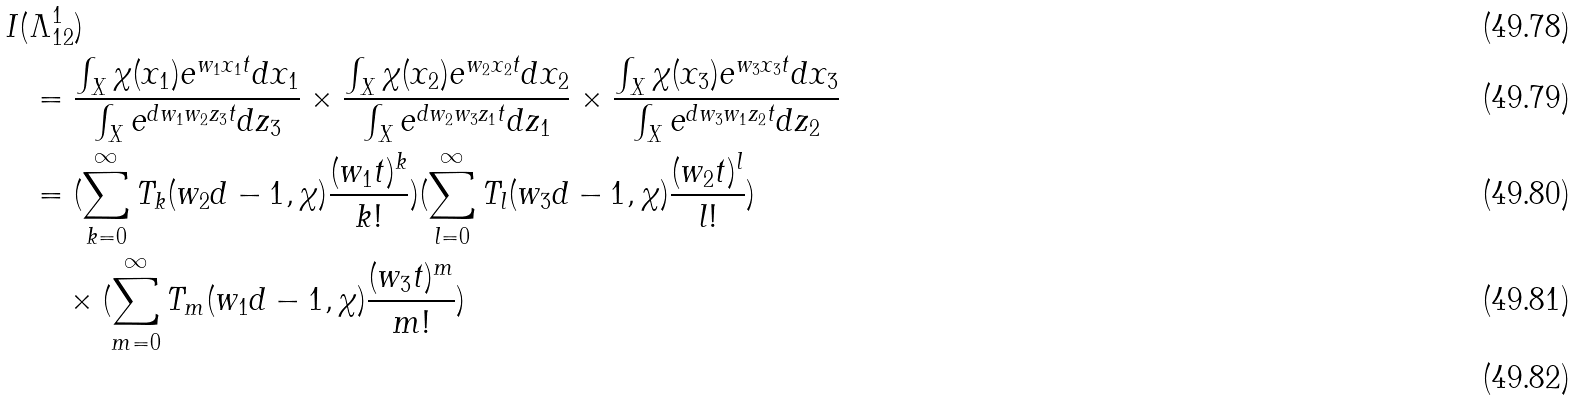Convert formula to latex. <formula><loc_0><loc_0><loc_500><loc_500>I ( & \Lambda _ { 1 2 } ^ { 1 } ) \\ & = \frac { \int _ { X } \chi ( x _ { 1 } ) e ^ { w _ { 1 } x _ { 1 } t } d x _ { 1 } } { \int _ { X } e ^ { d w _ { 1 } w _ { 2 } z _ { 3 } t } d z _ { 3 } } \times \frac { \int _ { X } \chi ( x _ { 2 } ) e ^ { w _ { 2 } x _ { 2 } t } d x _ { 2 } } { \int _ { X } e ^ { d w _ { 2 } w _ { 3 } z _ { 1 } t } d z _ { 1 } } \times \frac { \int _ { X } \chi ( x _ { 3 } ) e ^ { w _ { 3 } x _ { 3 } t } d x _ { 3 } } { \int _ { X } e ^ { d w _ { 3 } w _ { 1 } z _ { 2 } t } d z _ { 2 } } \\ & = ( \sum _ { k = 0 } ^ { \infty } T _ { k } ( w _ { 2 } d - 1 , \chi ) \frac { ( w _ { 1 } t ) ^ { k } } { k ! } ) ( \sum _ { l = 0 } ^ { \infty } T _ { l } ( w _ { 3 } d - 1 , \chi ) \frac { ( w _ { 2 } t ) ^ { l } } { l ! } ) \\ & \quad \times ( \sum _ { m = 0 } ^ { \infty } T _ { m } ( w _ { 1 } d - 1 , \chi ) \frac { ( w _ { 3 } t ) ^ { m } } { m ! } ) \\</formula> 